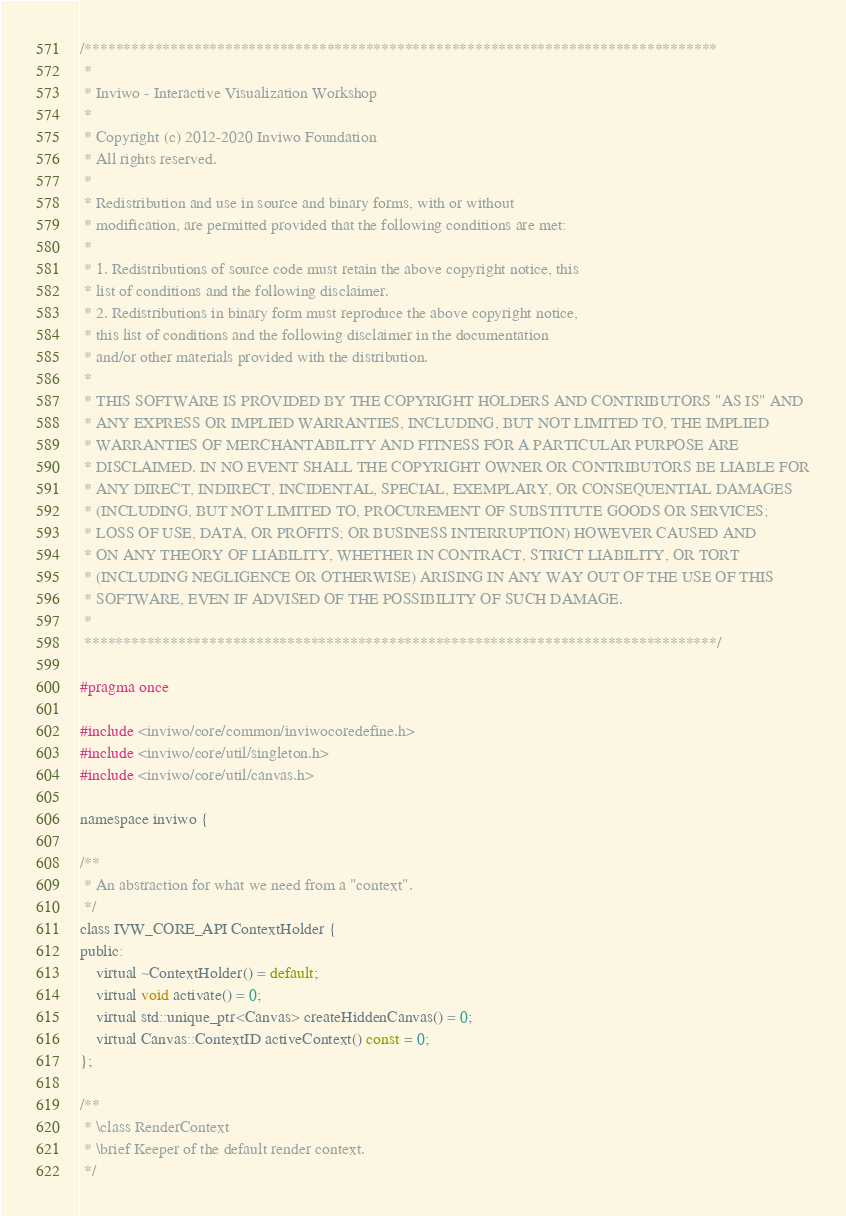<code> <loc_0><loc_0><loc_500><loc_500><_C_>
/*********************************************************************************
 *
 * Inviwo - Interactive Visualization Workshop
 *
 * Copyright (c) 2012-2020 Inviwo Foundation
 * All rights reserved.
 *
 * Redistribution and use in source and binary forms, with or without
 * modification, are permitted provided that the following conditions are met:
 *
 * 1. Redistributions of source code must retain the above copyright notice, this
 * list of conditions and the following disclaimer.
 * 2. Redistributions in binary form must reproduce the above copyright notice,
 * this list of conditions and the following disclaimer in the documentation
 * and/or other materials provided with the distribution.
 *
 * THIS SOFTWARE IS PROVIDED BY THE COPYRIGHT HOLDERS AND CONTRIBUTORS "AS IS" AND
 * ANY EXPRESS OR IMPLIED WARRANTIES, INCLUDING, BUT NOT LIMITED TO, THE IMPLIED
 * WARRANTIES OF MERCHANTABILITY AND FITNESS FOR A PARTICULAR PURPOSE ARE
 * DISCLAIMED. IN NO EVENT SHALL THE COPYRIGHT OWNER OR CONTRIBUTORS BE LIABLE FOR
 * ANY DIRECT, INDIRECT, INCIDENTAL, SPECIAL, EXEMPLARY, OR CONSEQUENTIAL DAMAGES
 * (INCLUDING, BUT NOT LIMITED TO, PROCUREMENT OF SUBSTITUTE GOODS OR SERVICES;
 * LOSS OF USE, DATA, OR PROFITS; OR BUSINESS INTERRUPTION) HOWEVER CAUSED AND
 * ON ANY THEORY OF LIABILITY, WHETHER IN CONTRACT, STRICT LIABILITY, OR TORT
 * (INCLUDING NEGLIGENCE OR OTHERWISE) ARISING IN ANY WAY OUT OF THE USE OF THIS
 * SOFTWARE, EVEN IF ADVISED OF THE POSSIBILITY OF SUCH DAMAGE.
 *
 *********************************************************************************/

#pragma once

#include <inviwo/core/common/inviwocoredefine.h>
#include <inviwo/core/util/singleton.h>
#include <inviwo/core/util/canvas.h>

namespace inviwo {

/**
 * An abstraction for what we need from a "context".
 */
class IVW_CORE_API ContextHolder {
public:
    virtual ~ContextHolder() = default;
    virtual void activate() = 0;
    virtual std::unique_ptr<Canvas> createHiddenCanvas() = 0;
    virtual Canvas::ContextID activeContext() const = 0;
};

/**
 * \class RenderContext
 * \brief Keeper of the default render context.
 */</code> 